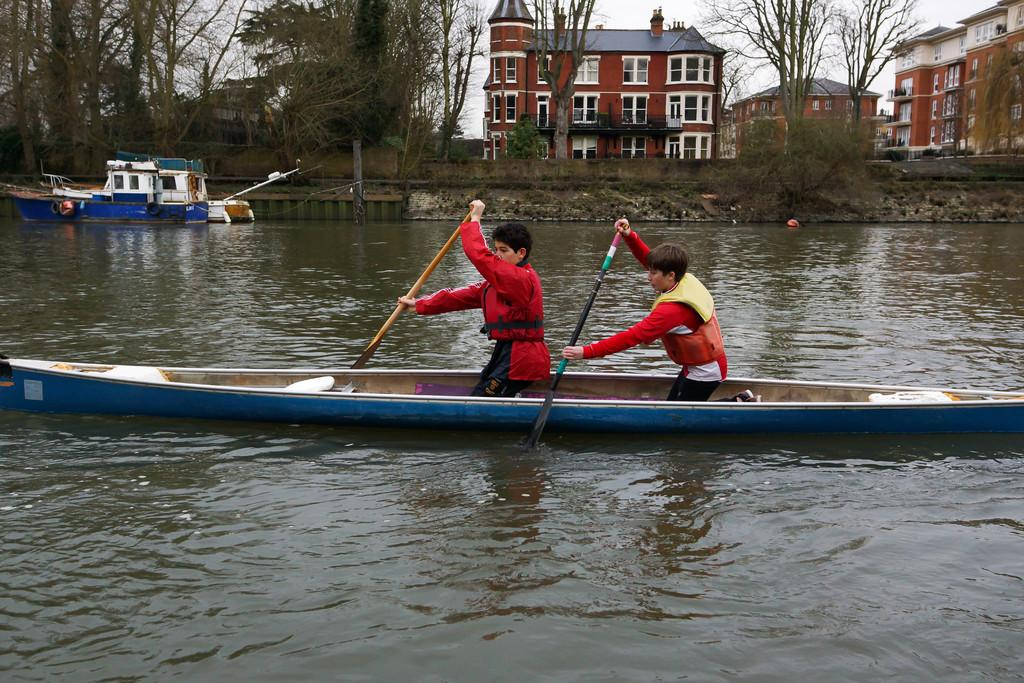How many kids are in the boat in the image? There are two kids in the boat in the image. What are the kids doing in the boat? The kids are holding oars in the image. What can be seen in the background of the image? There are trees and buildings with windows in the background. What is the condition of the sky in the image? The sky is clear in the image. What type of plastic material is covering the kids in the image? There is no plastic material covering the kids in the image. Are the kids' parents present in the image? The presence of the kids' parents cannot be determined from the image. What is the sleeping arrangement for the kids in the image? There is no indication of sleeping arrangements in the image, as the kids are in a boat holding oars. 